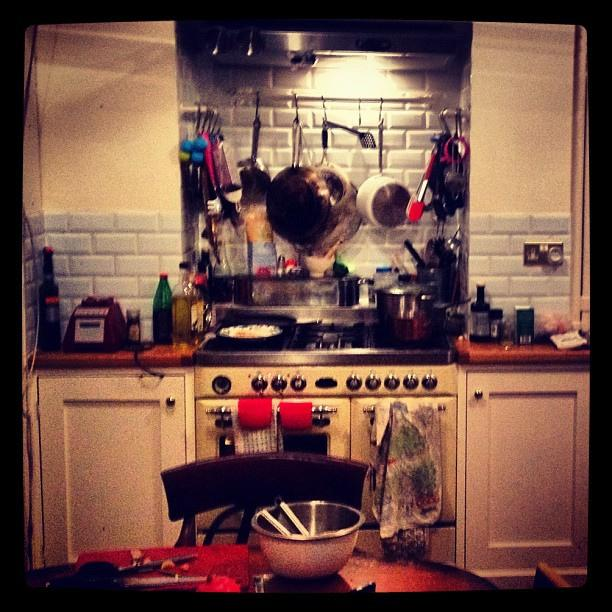What items are found on the wall? pots 